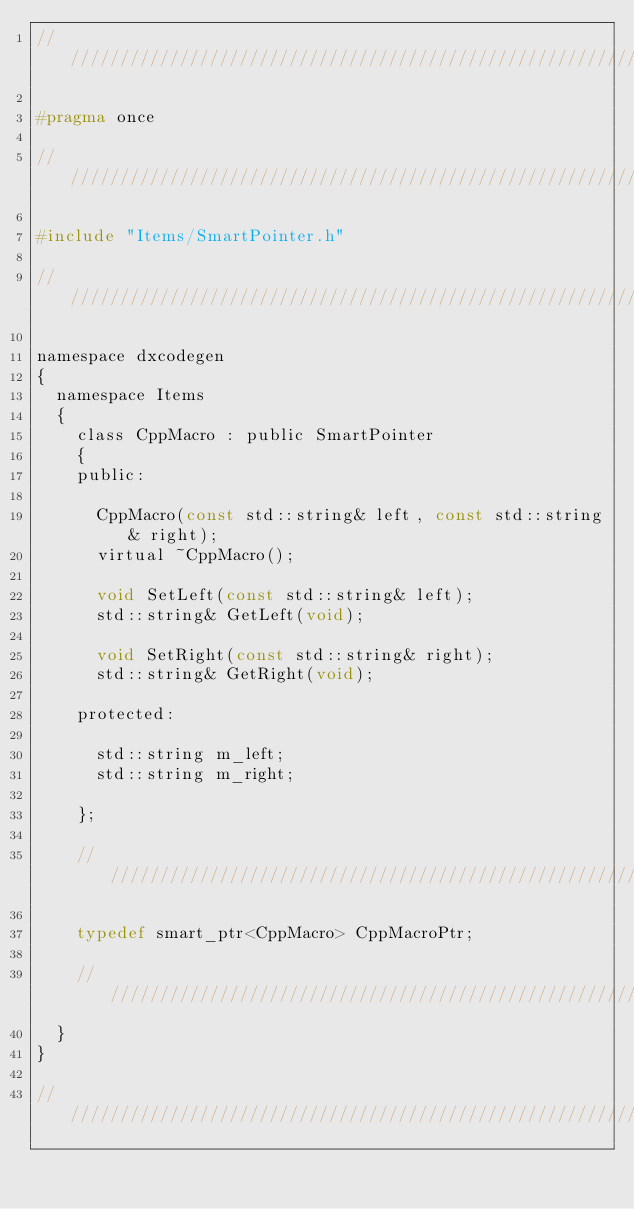<code> <loc_0><loc_0><loc_500><loc_500><_C_>////////////////////////////////////////////////////////////////////////////////

#pragma once

////////////////////////////////////////////////////////////////////////////////

#include "Items/SmartPointer.h"

////////////////////////////////////////////////////////////////////////////////

namespace dxcodegen
{
  namespace Items
  {
    class CppMacro : public SmartPointer
    {
    public:

      CppMacro(const std::string& left, const std::string& right);
      virtual ~CppMacro();

      void SetLeft(const std::string& left);
      std::string& GetLeft(void);

      void SetRight(const std::string& right);
      std::string& GetRight(void);

    protected:

      std::string m_left;
      std::string m_right;

    };

    ////////////////////////////////////////////////////////////////////////////

    typedef smart_ptr<CppMacro> CppMacroPtr;

    ////////////////////////////////////////////////////////////////////////////
  }
}

////////////////////////////////////////////////////////////////////////////////
</code> 